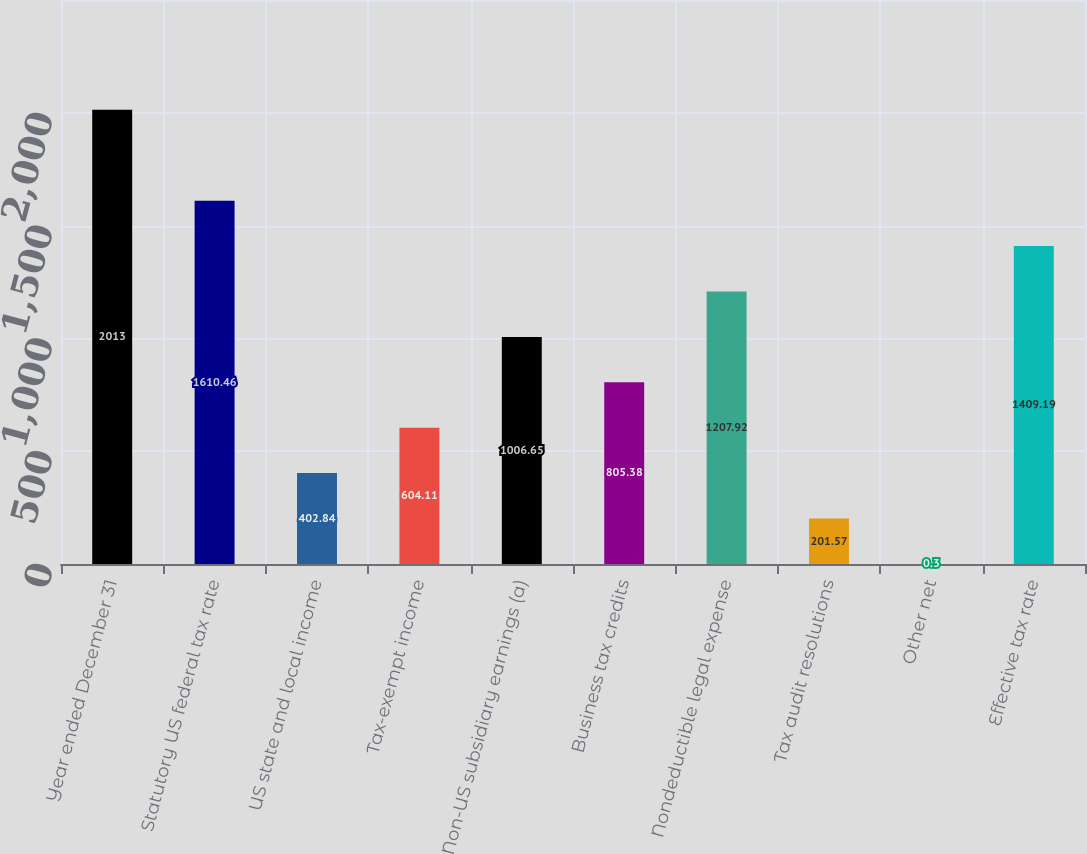<chart> <loc_0><loc_0><loc_500><loc_500><bar_chart><fcel>Year ended December 31<fcel>Statutory US federal tax rate<fcel>US state and local income<fcel>Tax-exempt income<fcel>Non-US subsidiary earnings (a)<fcel>Business tax credits<fcel>Nondeductible legal expense<fcel>Tax audit resolutions<fcel>Other net<fcel>Effective tax rate<nl><fcel>2013<fcel>1610.46<fcel>402.84<fcel>604.11<fcel>1006.65<fcel>805.38<fcel>1207.92<fcel>201.57<fcel>0.3<fcel>1409.19<nl></chart> 